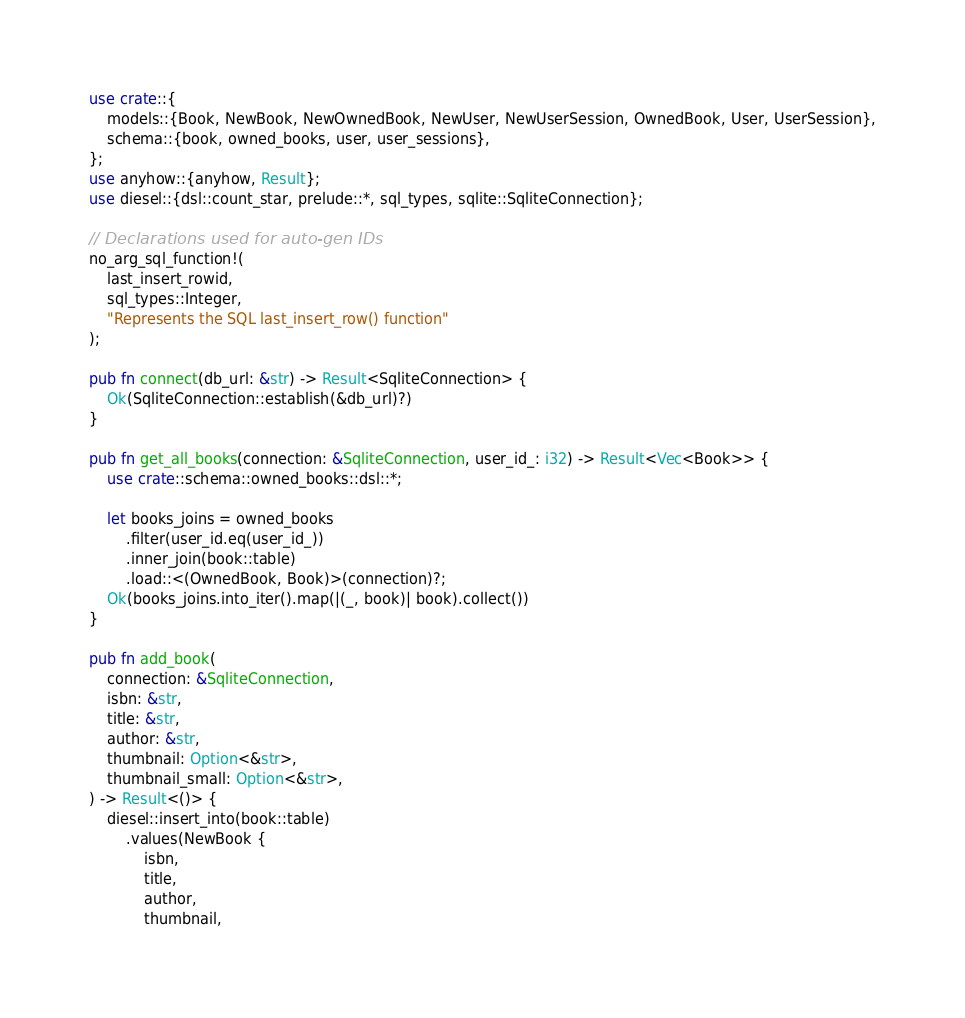<code> <loc_0><loc_0><loc_500><loc_500><_Rust_>use crate::{
    models::{Book, NewBook, NewOwnedBook, NewUser, NewUserSession, OwnedBook, User, UserSession},
    schema::{book, owned_books, user, user_sessions},
};
use anyhow::{anyhow, Result};
use diesel::{dsl::count_star, prelude::*, sql_types, sqlite::SqliteConnection};

// Declarations used for auto-gen IDs
no_arg_sql_function!(
    last_insert_rowid,
    sql_types::Integer,
    "Represents the SQL last_insert_row() function"
);

pub fn connect(db_url: &str) -> Result<SqliteConnection> {
    Ok(SqliteConnection::establish(&db_url)?)
}

pub fn get_all_books(connection: &SqliteConnection, user_id_: i32) -> Result<Vec<Book>> {
    use crate::schema::owned_books::dsl::*;

    let books_joins = owned_books
        .filter(user_id.eq(user_id_))
        .inner_join(book::table)
        .load::<(OwnedBook, Book)>(connection)?;
    Ok(books_joins.into_iter().map(|(_, book)| book).collect())
}

pub fn add_book(
    connection: &SqliteConnection,
    isbn: &str,
    title: &str,
    author: &str,
    thumbnail: Option<&str>,
    thumbnail_small: Option<&str>,
) -> Result<()> {
    diesel::insert_into(book::table)
        .values(NewBook {
            isbn,
            title,
            author,
            thumbnail,</code> 